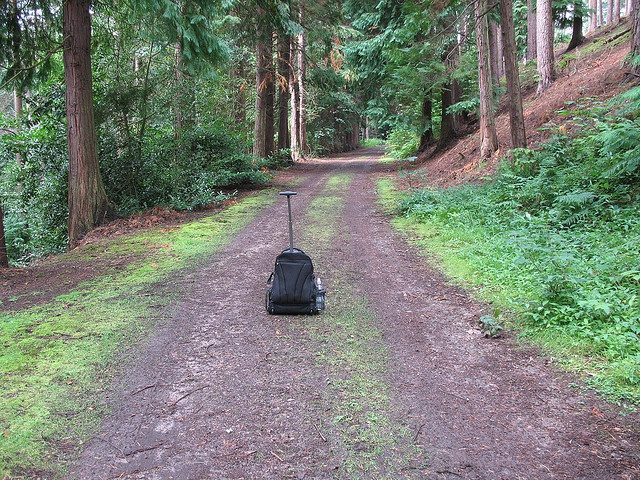Describe the objects in this image and their specific colors. I can see backpack in black, gray, and darkblue tones and bottle in black, gray, darkgray, and lavender tones in this image. 